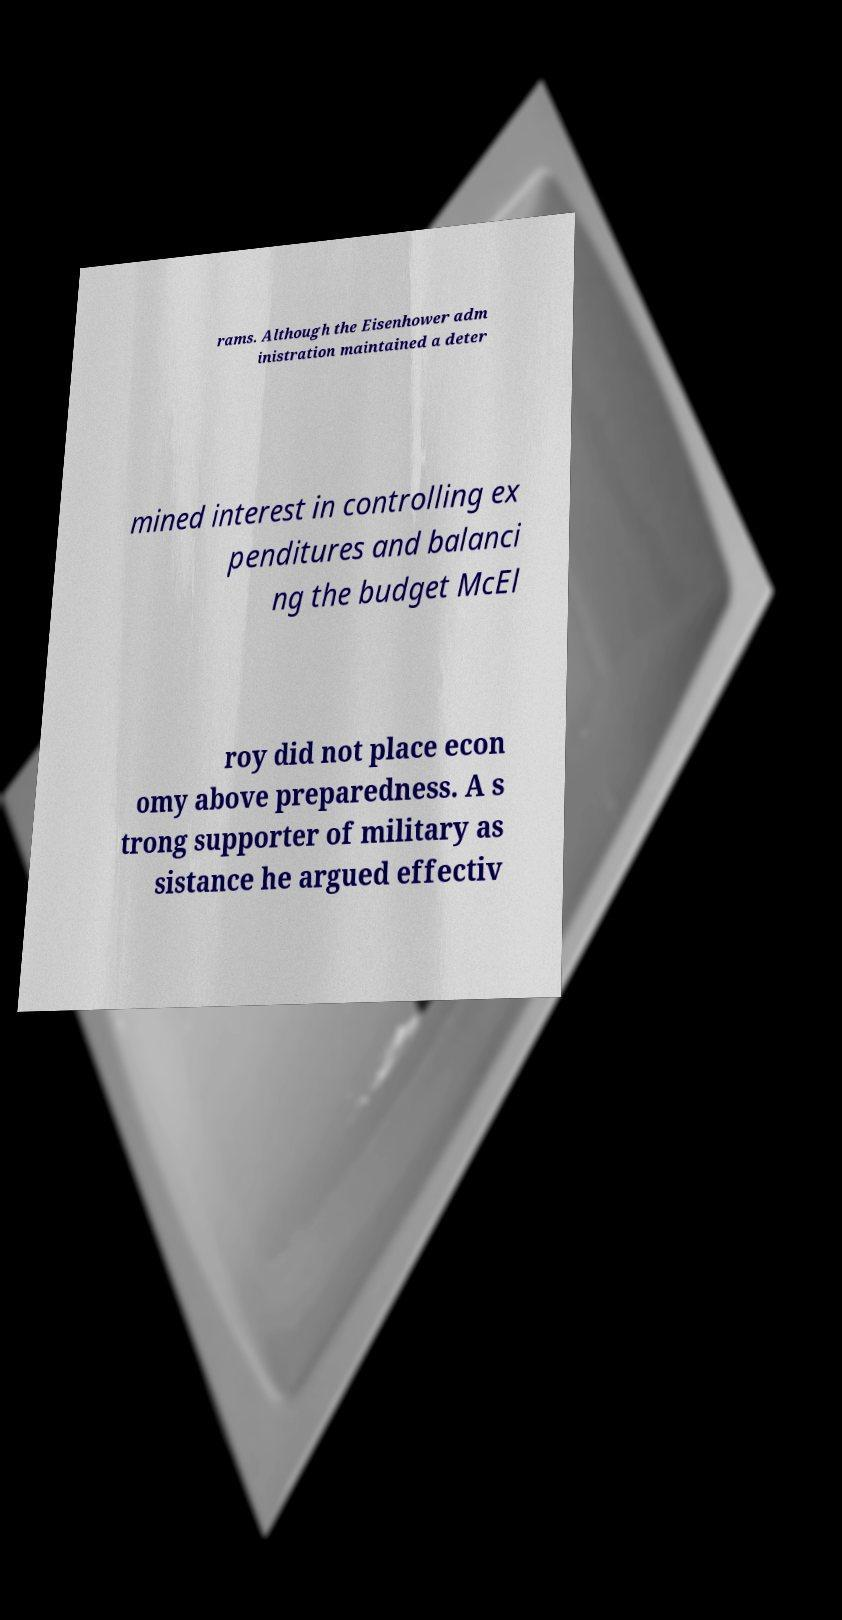Could you assist in decoding the text presented in this image and type it out clearly? rams. Although the Eisenhower adm inistration maintained a deter mined interest in controlling ex penditures and balanci ng the budget McEl roy did not place econ omy above preparedness. A s trong supporter of military as sistance he argued effectiv 